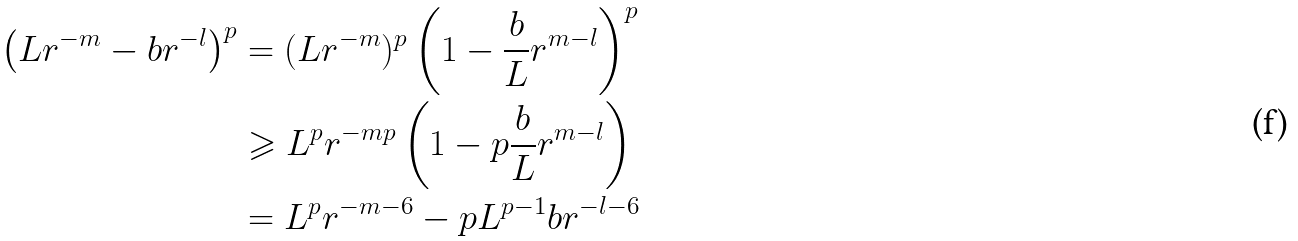<formula> <loc_0><loc_0><loc_500><loc_500>\left ( L r ^ { - m } - b r ^ { - l } \right ) ^ { p } & = ( L r ^ { - m } ) ^ { p } \left ( 1 - \frac { b } { L } r ^ { m - l } \right ) ^ { p } \\ & \geqslant L ^ { p } r ^ { - m p } \left ( 1 - p \frac { b } { L } r ^ { m - l } \right ) \\ & = L ^ { p } r ^ { - m - 6 } - p L ^ { p - 1 } b r ^ { - l - 6 }</formula> 